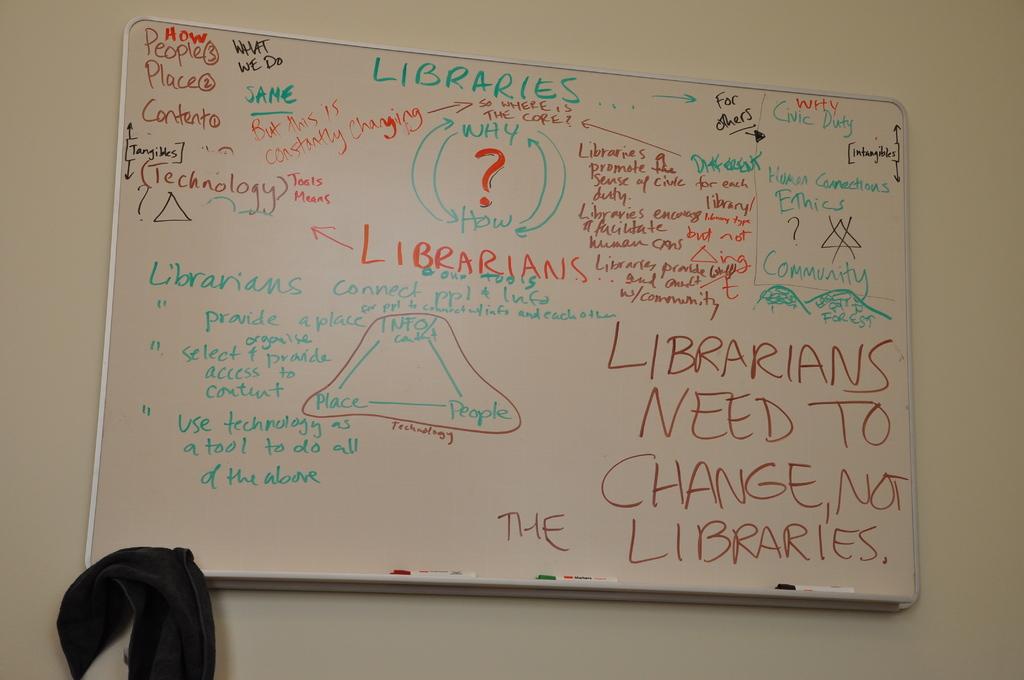What is the word in green on the top of the whiteboard?
Offer a terse response. Libraries. What needs to change according to the whiteboard?
Offer a terse response. Librarians. 